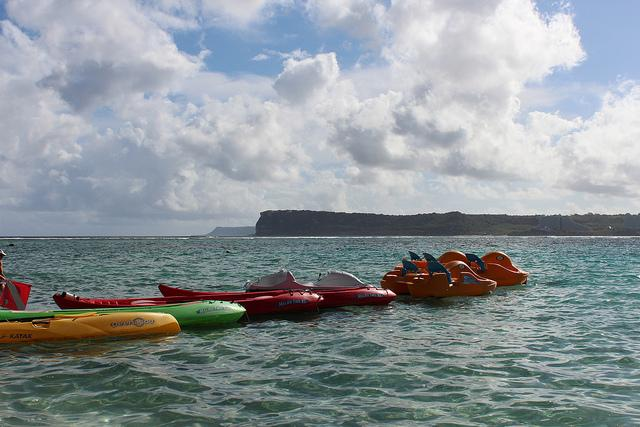What is one of the biggest risks in this environment? Please explain your reasoning. drowning. The risk is drowning. 